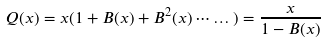Convert formula to latex. <formula><loc_0><loc_0><loc_500><loc_500>Q ( x ) = x ( 1 + B ( x ) + B ^ { 2 } ( x ) \cdots \dots ) = \frac { x } { 1 - B ( x ) }</formula> 